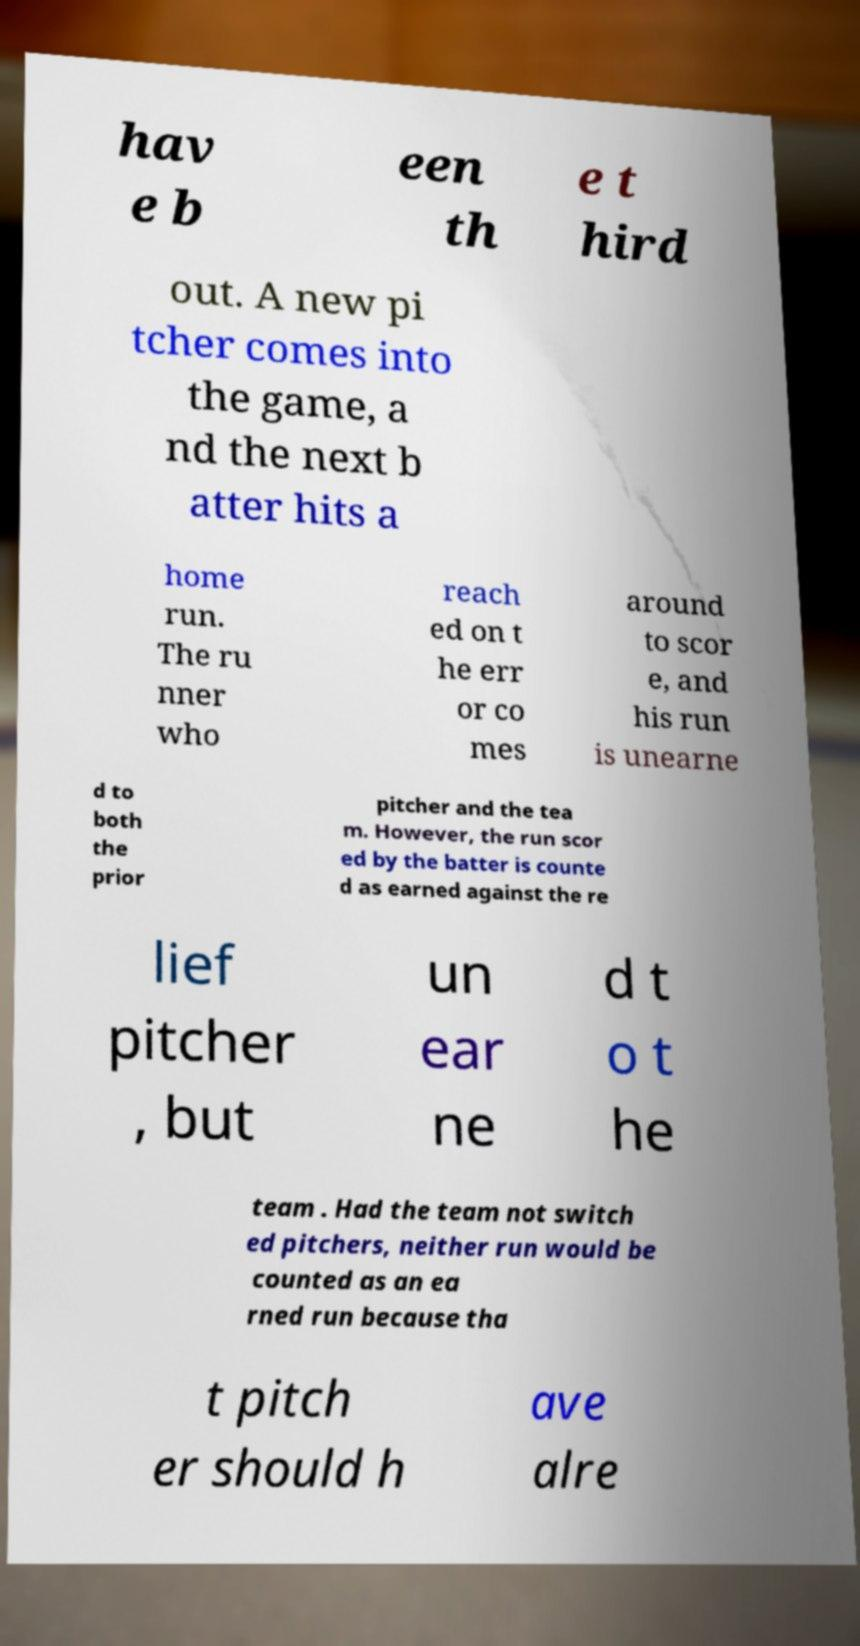Can you read and provide the text displayed in the image?This photo seems to have some interesting text. Can you extract and type it out for me? hav e b een th e t hird out. A new pi tcher comes into the game, a nd the next b atter hits a home run. The ru nner who reach ed on t he err or co mes around to scor e, and his run is unearne d to both the prior pitcher and the tea m. However, the run scor ed by the batter is counte d as earned against the re lief pitcher , but un ear ne d t o t he team . Had the team not switch ed pitchers, neither run would be counted as an ea rned run because tha t pitch er should h ave alre 